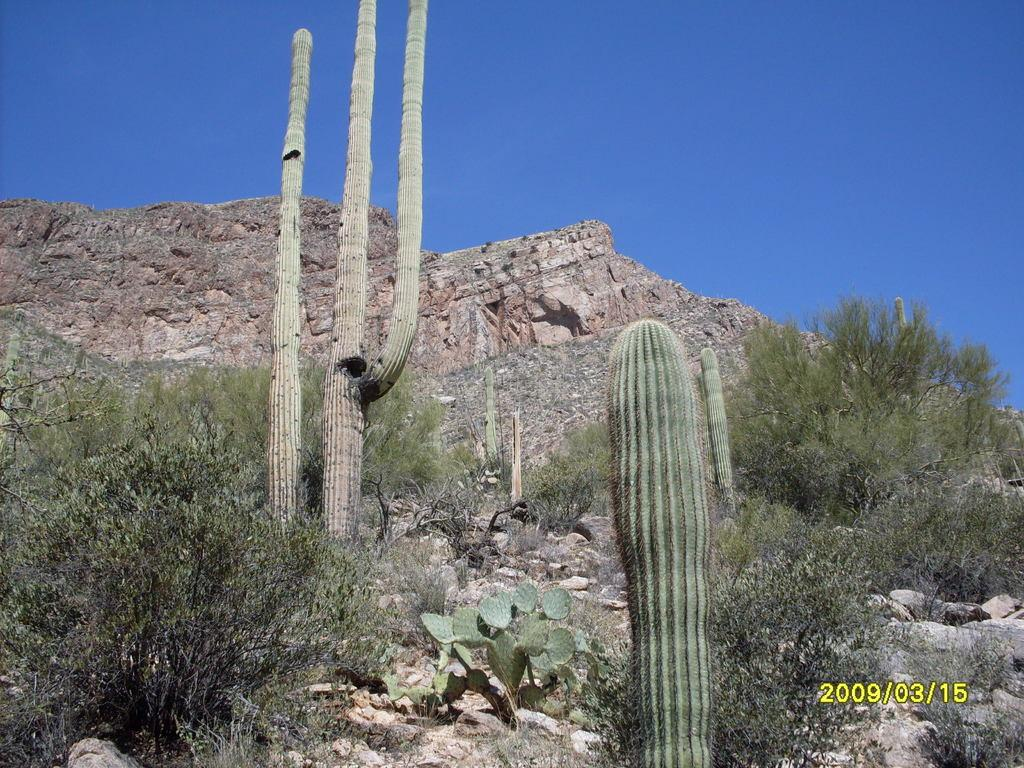What type of landform is present in the image? There is a hill in the image. What else can be seen in the image besides the hill? There are plants in the image. What is visible at the top of the image? The sky is visible at the top of the image. Where are the numbers located in the image? The numbers are at the bottom right of the image. What type of plastic object can be seen on the hill in the image? There is no plastic object present on the hill in the image. How many times does the person in the image sneeze? There is no person present in the image, so it is not possible to determine how many times they sneeze. 